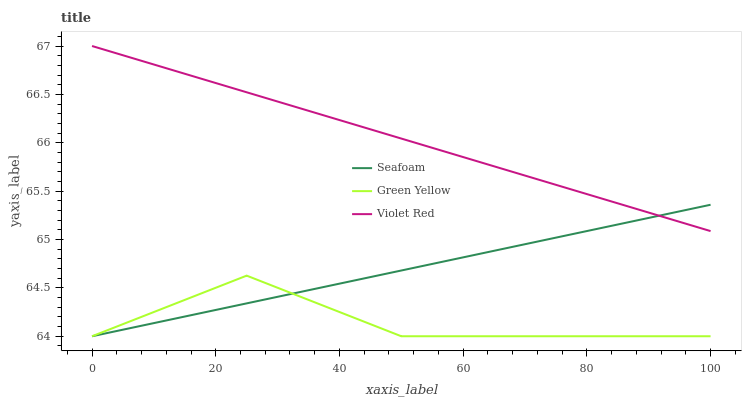Does Green Yellow have the minimum area under the curve?
Answer yes or no. Yes. Does Violet Red have the maximum area under the curve?
Answer yes or no. Yes. Does Seafoam have the minimum area under the curve?
Answer yes or no. No. Does Seafoam have the maximum area under the curve?
Answer yes or no. No. Is Seafoam the smoothest?
Answer yes or no. Yes. Is Green Yellow the roughest?
Answer yes or no. Yes. Is Green Yellow the smoothest?
Answer yes or no. No. Is Seafoam the roughest?
Answer yes or no. No. Does Green Yellow have the lowest value?
Answer yes or no. Yes. Does Violet Red have the highest value?
Answer yes or no. Yes. Does Seafoam have the highest value?
Answer yes or no. No. Is Green Yellow less than Violet Red?
Answer yes or no. Yes. Is Violet Red greater than Green Yellow?
Answer yes or no. Yes. Does Seafoam intersect Green Yellow?
Answer yes or no. Yes. Is Seafoam less than Green Yellow?
Answer yes or no. No. Is Seafoam greater than Green Yellow?
Answer yes or no. No. Does Green Yellow intersect Violet Red?
Answer yes or no. No. 